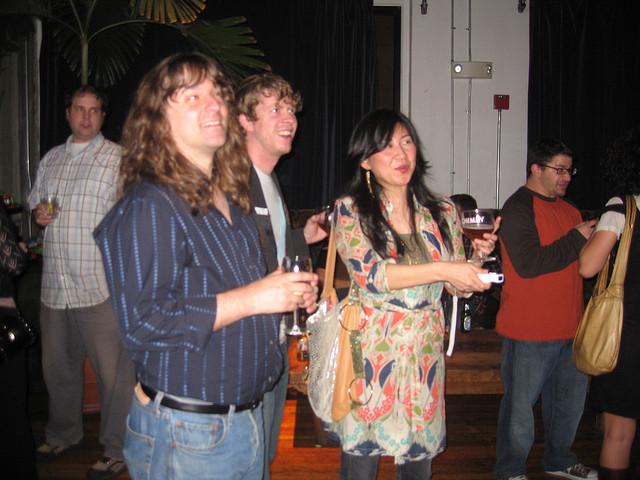What color is dominant?
Quick response, please. Black. How many women can you see in the picture?
Keep it brief. 2. How many people are in the image?
Keep it brief. 6. What is on these people's faces?
Give a very brief answer. Smiles. 